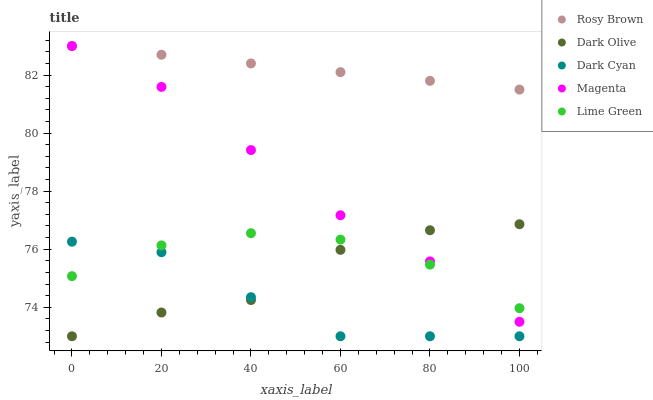Does Dark Cyan have the minimum area under the curve?
Answer yes or no. Yes. Does Rosy Brown have the maximum area under the curve?
Answer yes or no. Yes. Does Magenta have the minimum area under the curve?
Answer yes or no. No. Does Magenta have the maximum area under the curve?
Answer yes or no. No. Is Rosy Brown the smoothest?
Answer yes or no. Yes. Is Dark Olive the roughest?
Answer yes or no. Yes. Is Dark Cyan the smoothest?
Answer yes or no. No. Is Dark Cyan the roughest?
Answer yes or no. No. Does Dark Olive have the lowest value?
Answer yes or no. Yes. Does Magenta have the lowest value?
Answer yes or no. No. Does Rosy Brown have the highest value?
Answer yes or no. Yes. Does Dark Cyan have the highest value?
Answer yes or no. No. Is Dark Olive less than Rosy Brown?
Answer yes or no. Yes. Is Rosy Brown greater than Lime Green?
Answer yes or no. Yes. Does Dark Olive intersect Magenta?
Answer yes or no. Yes. Is Dark Olive less than Magenta?
Answer yes or no. No. Is Dark Olive greater than Magenta?
Answer yes or no. No. Does Dark Olive intersect Rosy Brown?
Answer yes or no. No. 